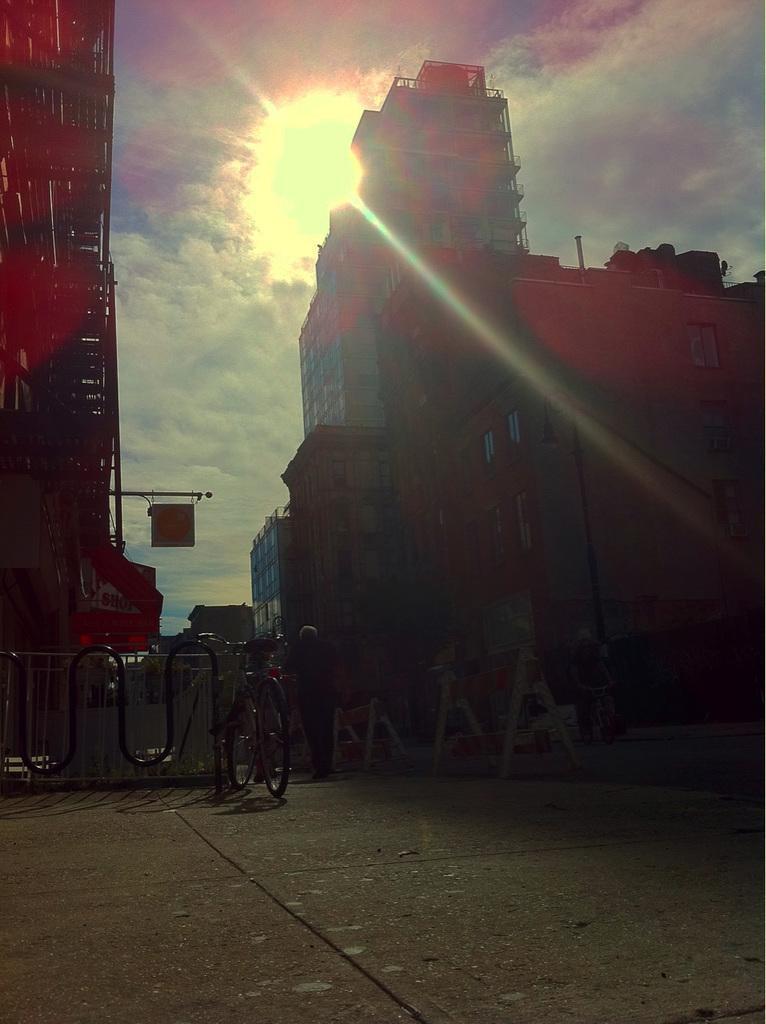Please provide a concise description of this image. In this image we can see a cycle placed in a rack, some boards and two people standing on the ground. On the backside we can see some buildings, a signboard, the sun and the sky which looks cloudy. 